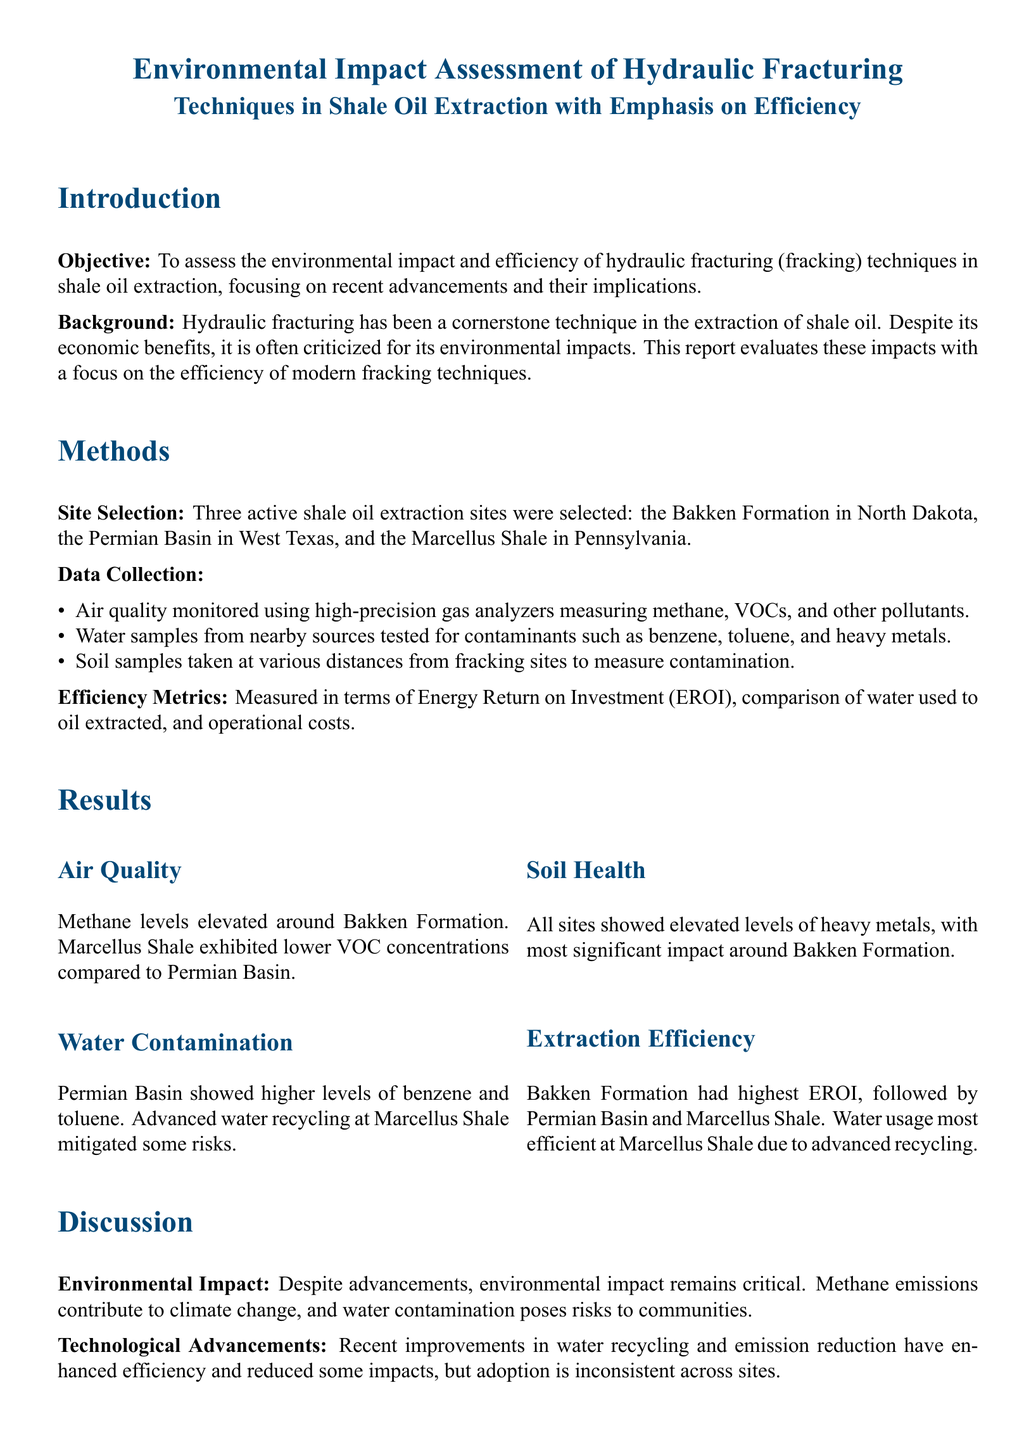What are the selected shale oil extraction sites? The document lists three active shale oil extraction sites: Bakken Formation, Permian Basin, and Marcellus Shale.
Answer: Bakken Formation, Permian Basin, Marcellus Shale What pollutant levels were monitored in the air quality section? The air quality monitoring focused on methane, VOCs, and other pollutants.
Answer: Methane, VOCs Which shale site had the highest EROI? The document states that Bakken Formation had the highest Energy Return on Investment (EROI) compared to others.
Answer: Bakken Formation What was noted about water recycling at Marcellus Shale? The report mentions that advanced water recycling at Marcellus Shale mitigated some risks of water contamination.
Answer: Advanced water recycling What were the recommendations given in the conclusion? The report provides several recommendations, including adopting stringent environmental regulations, investing in advanced technologies, and improving transparency.
Answer: Stringent environmental regulations Which site showed the most significant impact on soil health? The document highlights that the Bakken Formation exhibited the most significant impact regarding elevated heavy metal levels in soil samples.
Answer: Bakken Formation What is the primary objective of the report? The document states the objective is to assess the environmental impact and efficiency of hydraulic fracturing techniques in shale oil extraction.
Answer: Assess the environmental impact and efficiency Which site had the most efficient water usage? The document indicates that the Marcellus Shale had the most efficient water usage due to advanced recycling methods.
Answer: Marcellus Shale 